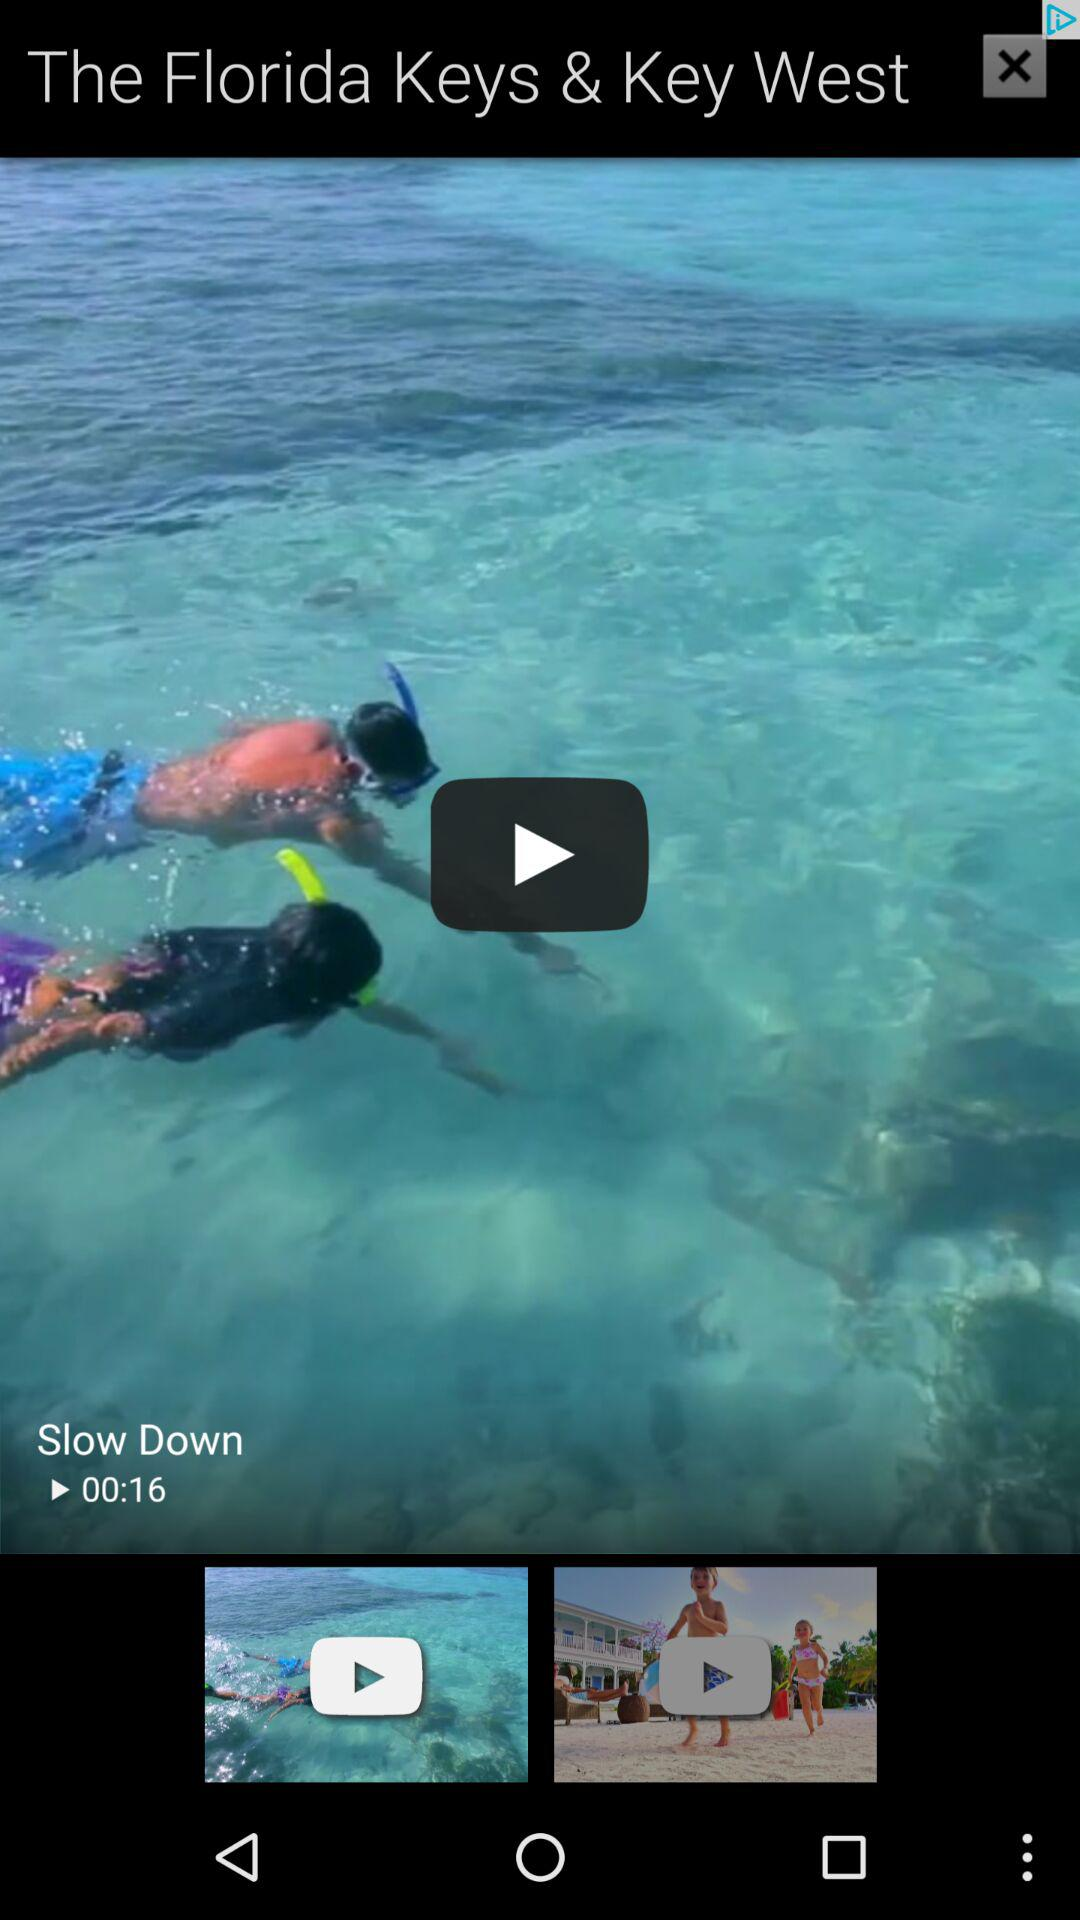How long is "Slow Down" video? It is 16 seconds long. 